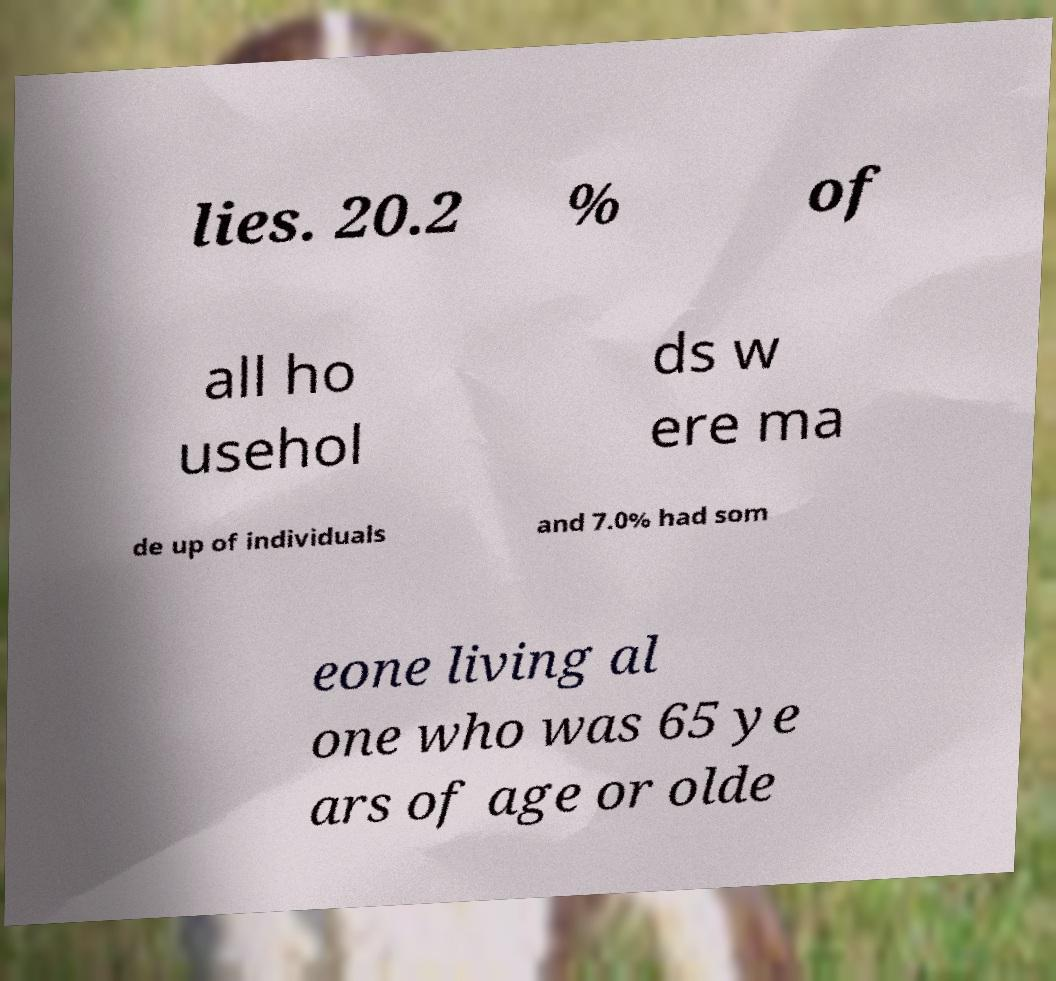I need the written content from this picture converted into text. Can you do that? lies. 20.2 % of all ho usehol ds w ere ma de up of individuals and 7.0% had som eone living al one who was 65 ye ars of age or olde 